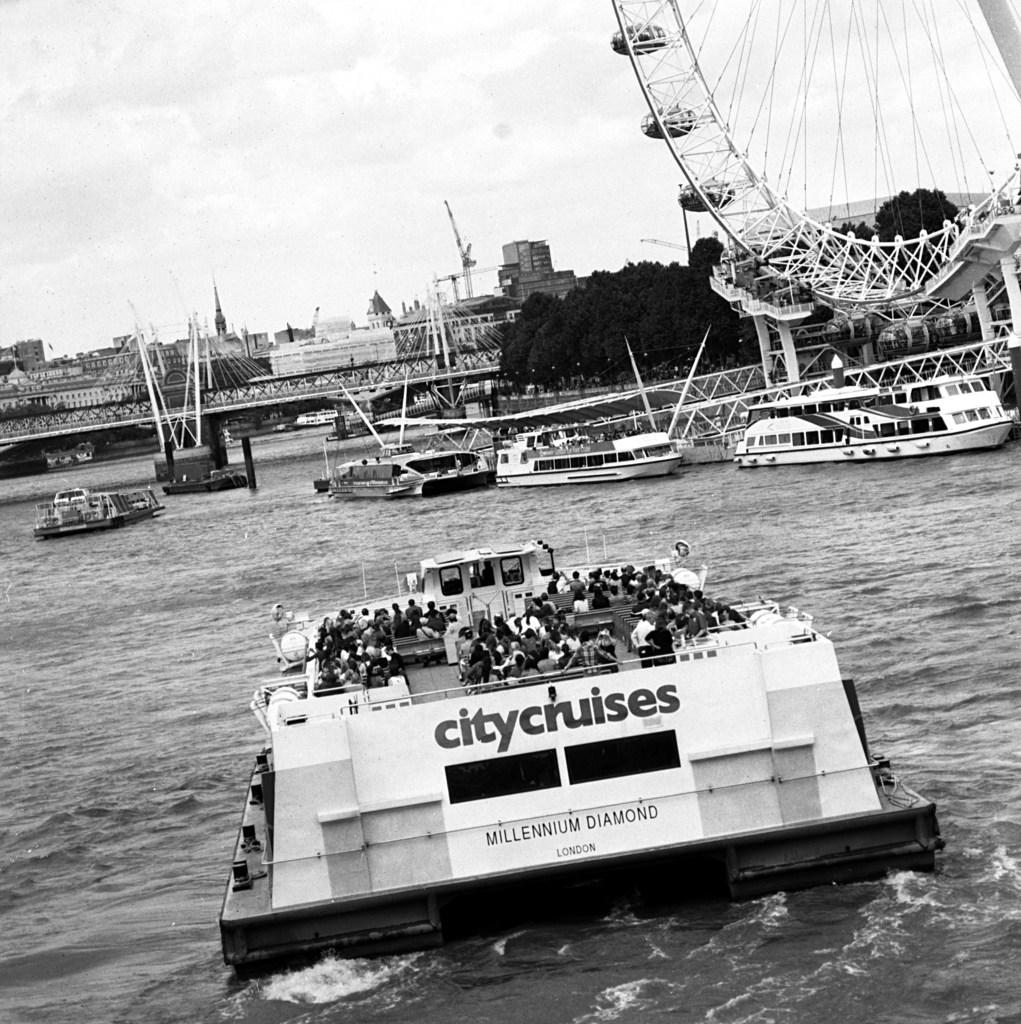<image>
Render a clear and concise summary of the photo. the name citycruises is on a boat on the water 